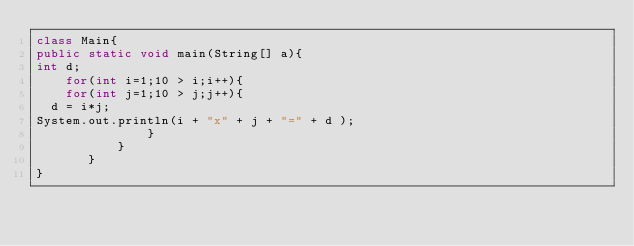<code> <loc_0><loc_0><loc_500><loc_500><_Java_>class Main{
public static void main(String[] a){
int d;
    for(int i=1;10 > i;i++){
    for(int j=1;10 > j;j++){
  d = i*j;
System.out.println(i + "x" + j + "=" + d );
               }
           }
       }
}            </code> 